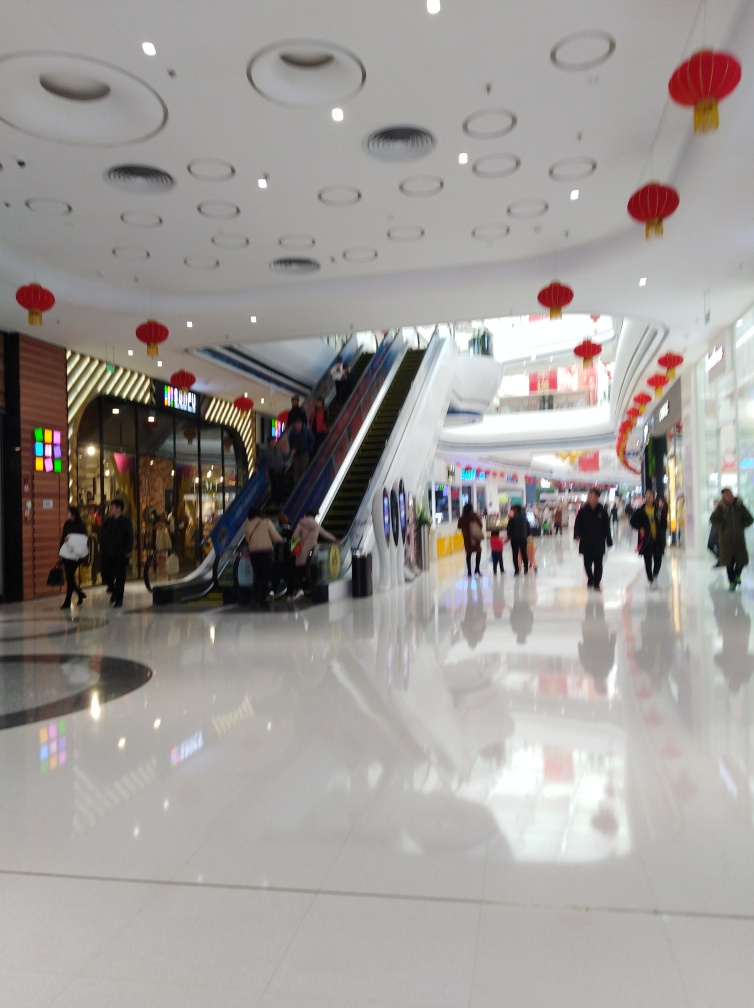How does the architecture contribute to the ambiance of the space? The mall's architecture, featuring a modern design with circular recessed lighting on the ceiling and an open layout, creates a contemporary and inviting atmosphere. The escalators add a sense of movement and accessibility, further contributing to the dynamic nature of the commercial space. Is there any indication of the type of shops present in the mall? While the image does not provide clear shop signage, the brightly colored storefronts and illuminated displays suggest a variety of retail options. The presence of both casual shoppers and individuals with shopping bags indicates a mix of possibly both high street and specialized stores. 